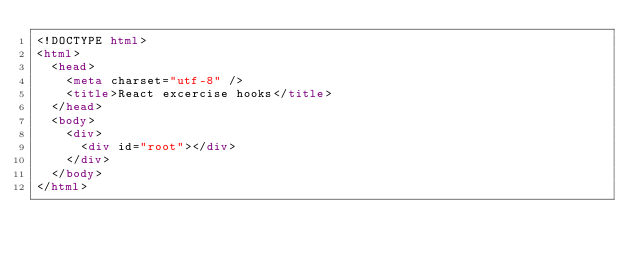Convert code to text. <code><loc_0><loc_0><loc_500><loc_500><_HTML_><!DOCTYPE html>
<html>
  <head>
    <meta charset="utf-8" />
    <title>React excercise hooks</title>
  </head>
  <body>
    <div>
      <div id="root"></div>
    </div>
  </body>
</html>
</code> 